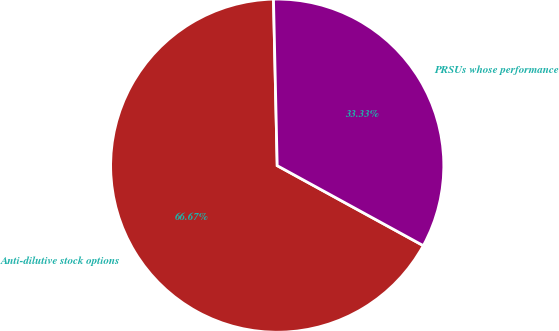Convert chart to OTSL. <chart><loc_0><loc_0><loc_500><loc_500><pie_chart><fcel>Anti-dilutive stock options<fcel>PRSUs whose performance<nl><fcel>66.67%<fcel>33.33%<nl></chart> 